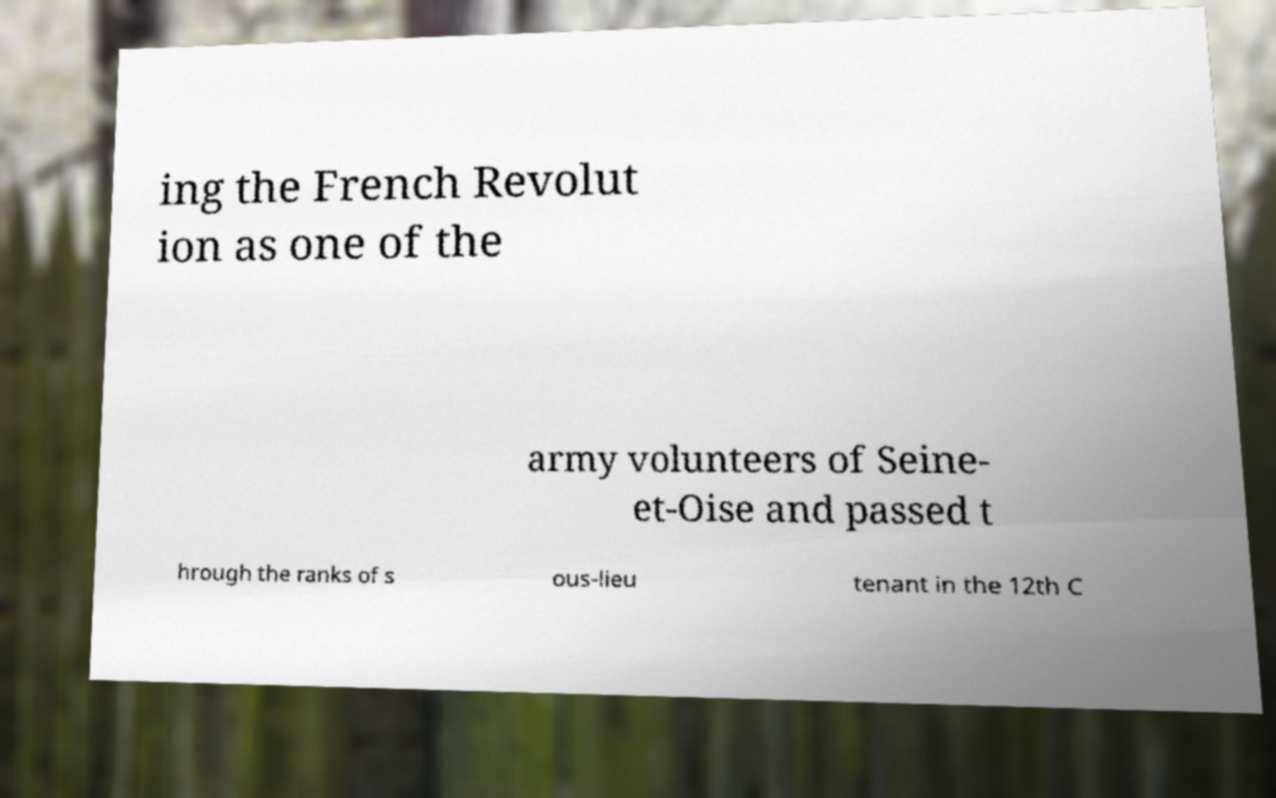Please identify and transcribe the text found in this image. ing the French Revolut ion as one of the army volunteers of Seine- et-Oise and passed t hrough the ranks of s ous-lieu tenant in the 12th C 